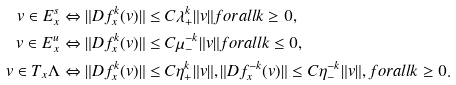Convert formula to latex. <formula><loc_0><loc_0><loc_500><loc_500>v \in E ^ { s } _ { x } & \Leftrightarrow \| D f ^ { k } _ { x } ( v ) \| \leq C \lambda _ { + } ^ { k } \| v \| f o r a l l k \geq 0 , \\ v \in E ^ { u } _ { x } & \Leftrightarrow \| D f ^ { k } _ { x } ( v ) \| \leq C \mu _ { - } ^ { - k } \| v \| f o r a l l k \leq 0 , \\ v \in T _ { x } \Lambda & \Leftrightarrow \| D f ^ { k } _ { x } ( v ) \| \leq C \eta _ { + } ^ { k } \| v \| , \| D f ^ { - k } _ { x } ( v ) \| \leq C \eta _ { - } ^ { - k } \| v \| , f o r a l l k \geq 0 .</formula> 